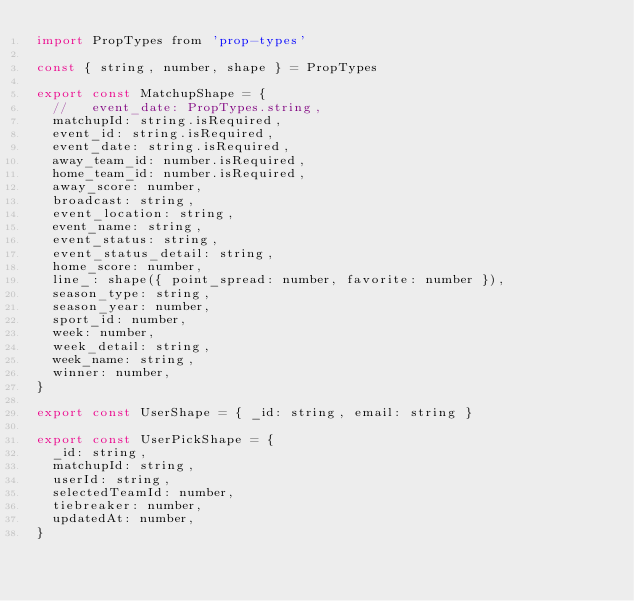<code> <loc_0><loc_0><loc_500><loc_500><_JavaScript_>import PropTypes from 'prop-types'

const { string, number, shape } = PropTypes

export const MatchupShape = {
  //   event_date: PropTypes.string,
  matchupId: string.isRequired,
  event_id: string.isRequired,
  event_date: string.isRequired,
  away_team_id: number.isRequired,
  home_team_id: number.isRequired,
  away_score: number,
  broadcast: string,
  event_location: string,
  event_name: string,
  event_status: string,
  event_status_detail: string,
  home_score: number,
  line_: shape({ point_spread: number, favorite: number }),
  season_type: string,
  season_year: number,
  sport_id: number,
  week: number,
  week_detail: string,
  week_name: string,
  winner: number,
}

export const UserShape = { _id: string, email: string }

export const UserPickShape = {
  _id: string,
  matchupId: string,
  userId: string,
  selectedTeamId: number,
  tiebreaker: number,
  updatedAt: number,
}
</code> 